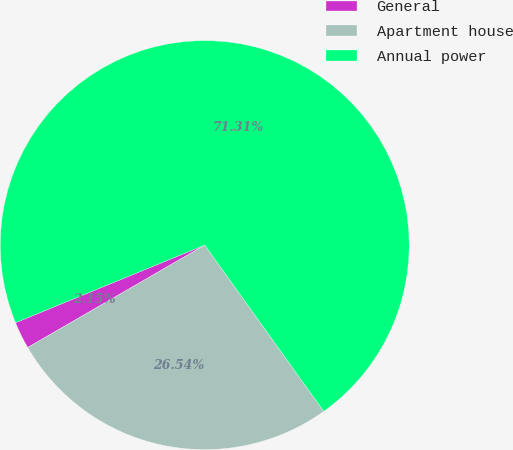<chart> <loc_0><loc_0><loc_500><loc_500><pie_chart><fcel>General<fcel>Apartment house<fcel>Annual power<nl><fcel>2.15%<fcel>26.54%<fcel>71.3%<nl></chart> 